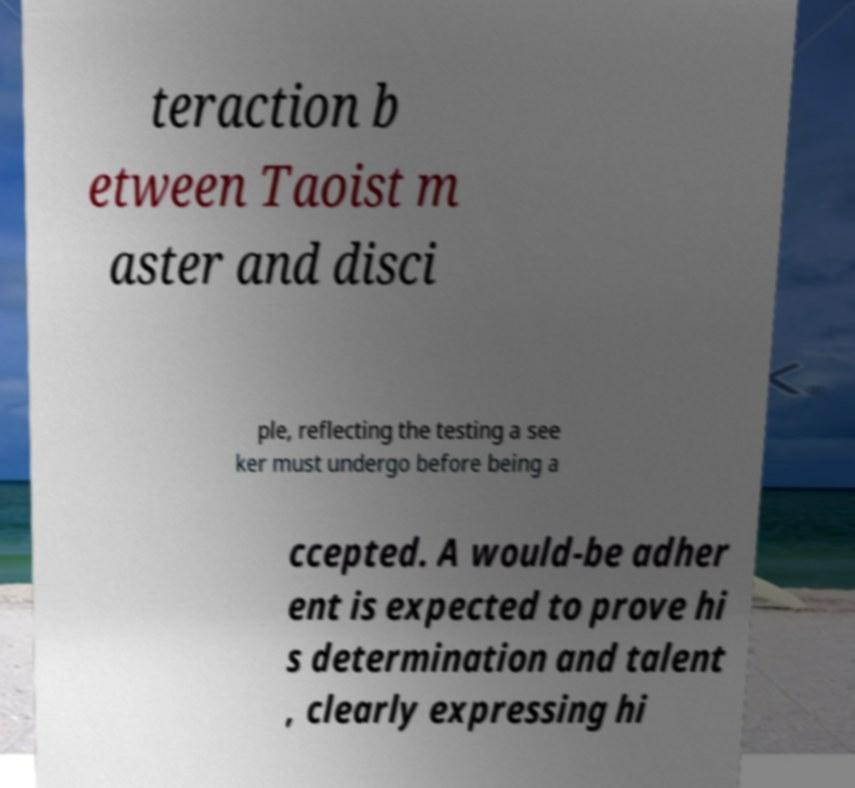Please read and relay the text visible in this image. What does it say? teraction b etween Taoist m aster and disci ple, reflecting the testing a see ker must undergo before being a ccepted. A would-be adher ent is expected to prove hi s determination and talent , clearly expressing hi 